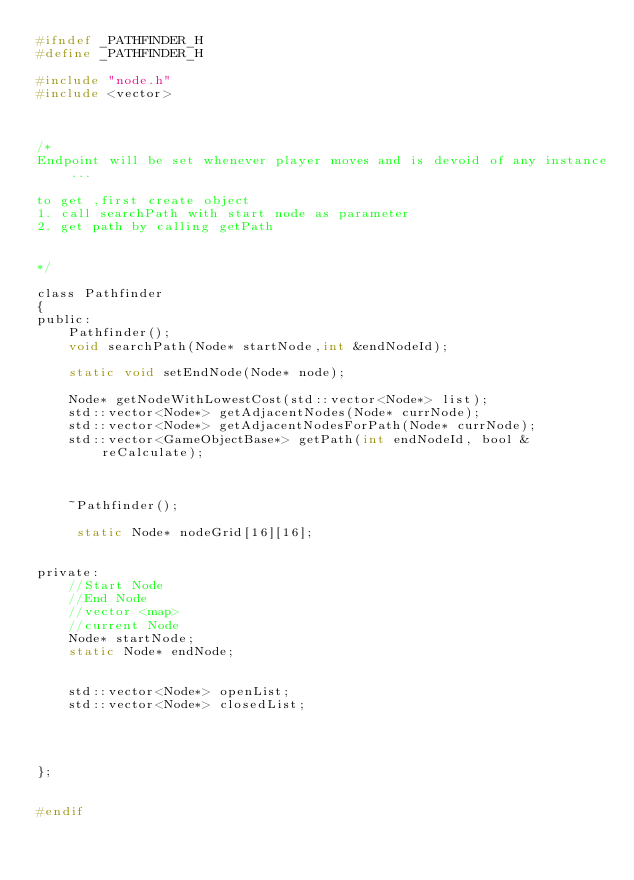<code> <loc_0><loc_0><loc_500><loc_500><_C_>#ifndef _PATHFINDER_H
#define _PATHFINDER_H

#include "node.h"
#include <vector>



/*
Endpoint will be set whenever player moves and is devoid of any instance...

to get ,first create object
1. call searchPath with start node as parameter 
2. get path by calling getPath


*/

class Pathfinder
{
public:
	Pathfinder();
	void searchPath(Node* startNode,int &endNodeId);

	static void setEndNode(Node* node);

	Node* getNodeWithLowestCost(std::vector<Node*> list);
	std::vector<Node*> getAdjacentNodes(Node* currNode);
	std::vector<Node*> getAdjacentNodesForPath(Node* currNode);
	std::vector<GameObjectBase*> getPath(int endNodeId, bool &reCalculate);



	~Pathfinder();
  
	 static Node* nodeGrid[16][16];


private:
	//Start Node 
	//End Node
	//vector <map>
	//current Node
	Node* startNode;
	static Node* endNode;
   

	std::vector<Node*> openList;
	std::vector<Node*> closedList;




};


#endif</code> 